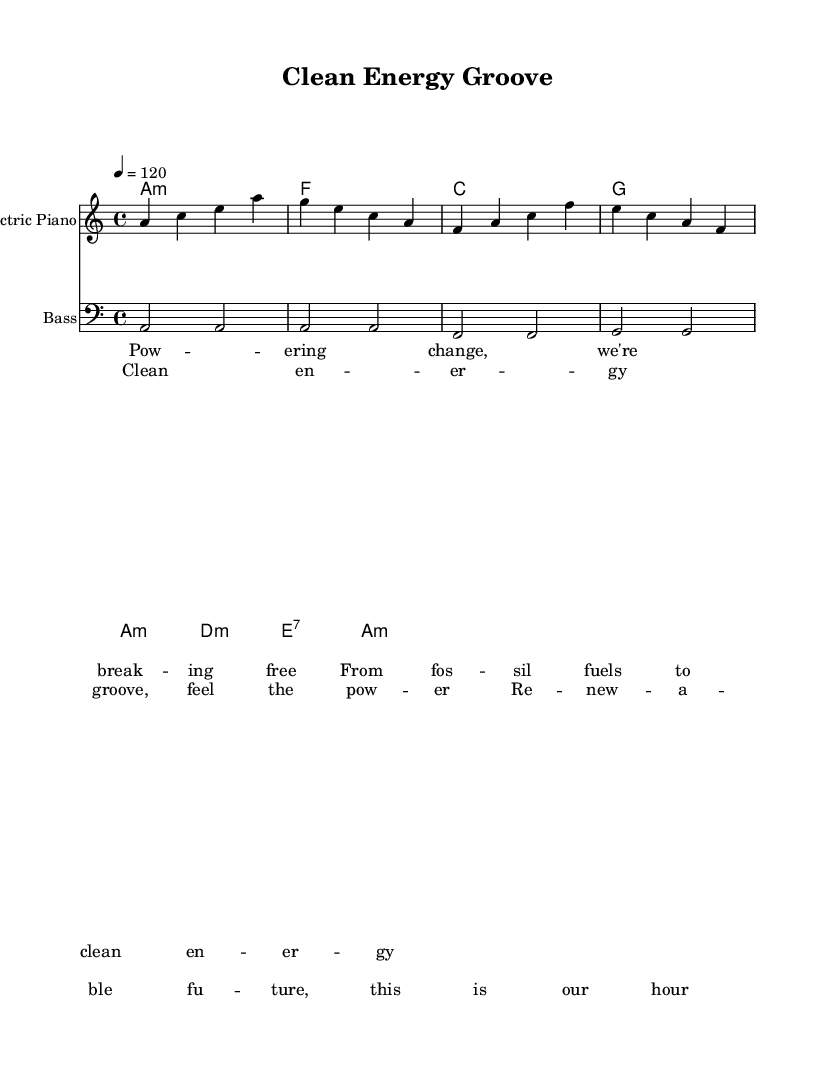What is the key signature of this music? The key signature is A minor, which has no sharps or flats. It is determined by the 'a' written at the beginning of the staff and the lack of accidentals next to the notes.
Answer: A minor What is the time signature of this music? The time signature is 4/4, indicated at the beginning of the score. This means there are four beats in a measure, and the quarter note gets one beat.
Answer: 4/4 What is the tempo marking of this piece? The tempo marking is 120 beats per minute, indicated in the score by '4 = 120'. This tells performers how fast to play the piece.
Answer: 120 Which instruments are included in the score? The score includes an Electric Piano and a Bass Guitar, as noted in the staff headings. This can be found under the respective instrument names at the beginning of each staff.
Answer: Electric Piano, Bass Guitar How many measures are in the first verse? There are four measures in the first verse. The verse is laid out clearly with lyrics that correspond to each measure of music.
Answer: 4 What is the overall theme of the lyrics? The lyrics emphasize the transition from fossil fuels to clean energy, portraying empowerment and a hopeful future, which aligns with the renewable energy message. This can be inferred from the phrases used in both the verse and chorus.
Answer: Clean energy transition What type of musical genre is this piece? This piece is categorized as Disco, evident from its upbeat tempo, groove-oriented feel, and lyrical focus on themes of empowerment and energy. These characteristics are typical of Disco music.
Answer: Disco 